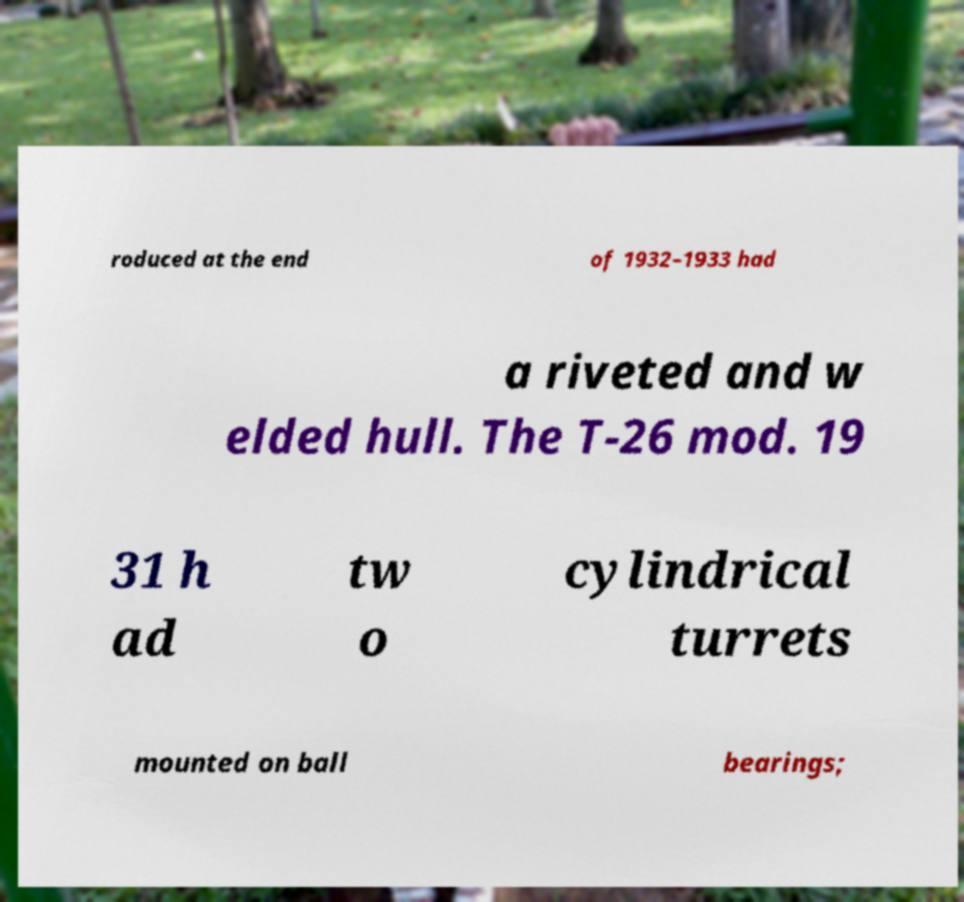Can you accurately transcribe the text from the provided image for me? roduced at the end of 1932–1933 had a riveted and w elded hull. The T-26 mod. 19 31 h ad tw o cylindrical turrets mounted on ball bearings; 